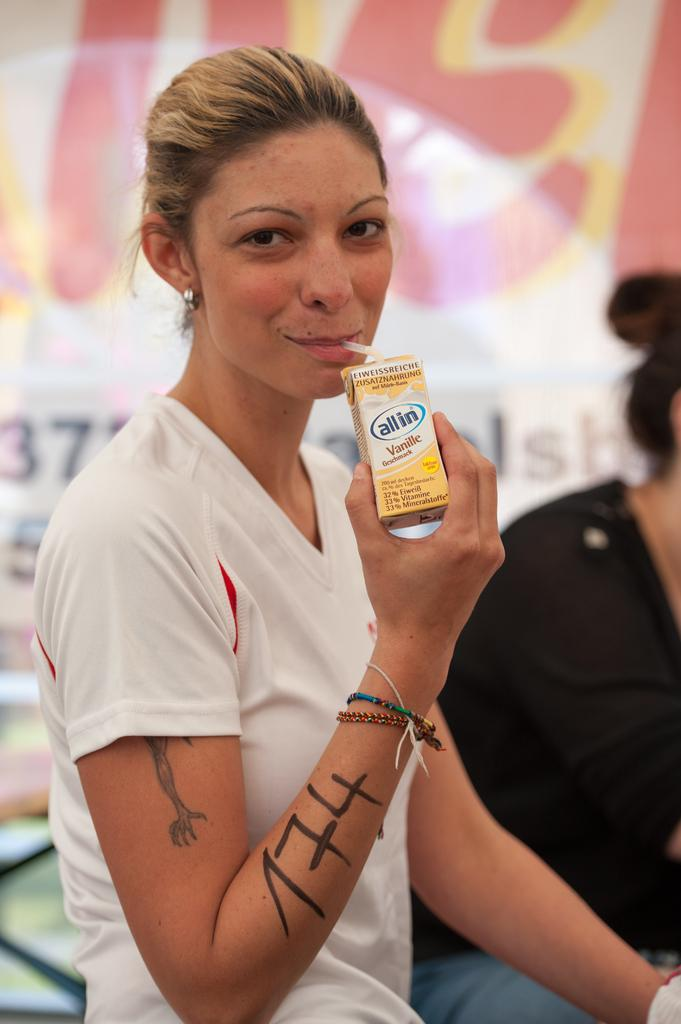How many women are in the image? There are two women in the image. Can you describe the clothing of one of the women? One of the women is wearing a white T-shirt. What is the woman in the white T-shirt doing in the image? The woman in the white T-shirt is drinking a milkshake. How does the woman in the white T-shirt help the person sitting on the seat in the image? There is no person sitting on a seat in the image, and the woman in the white T-shirt is not helping anyone. 